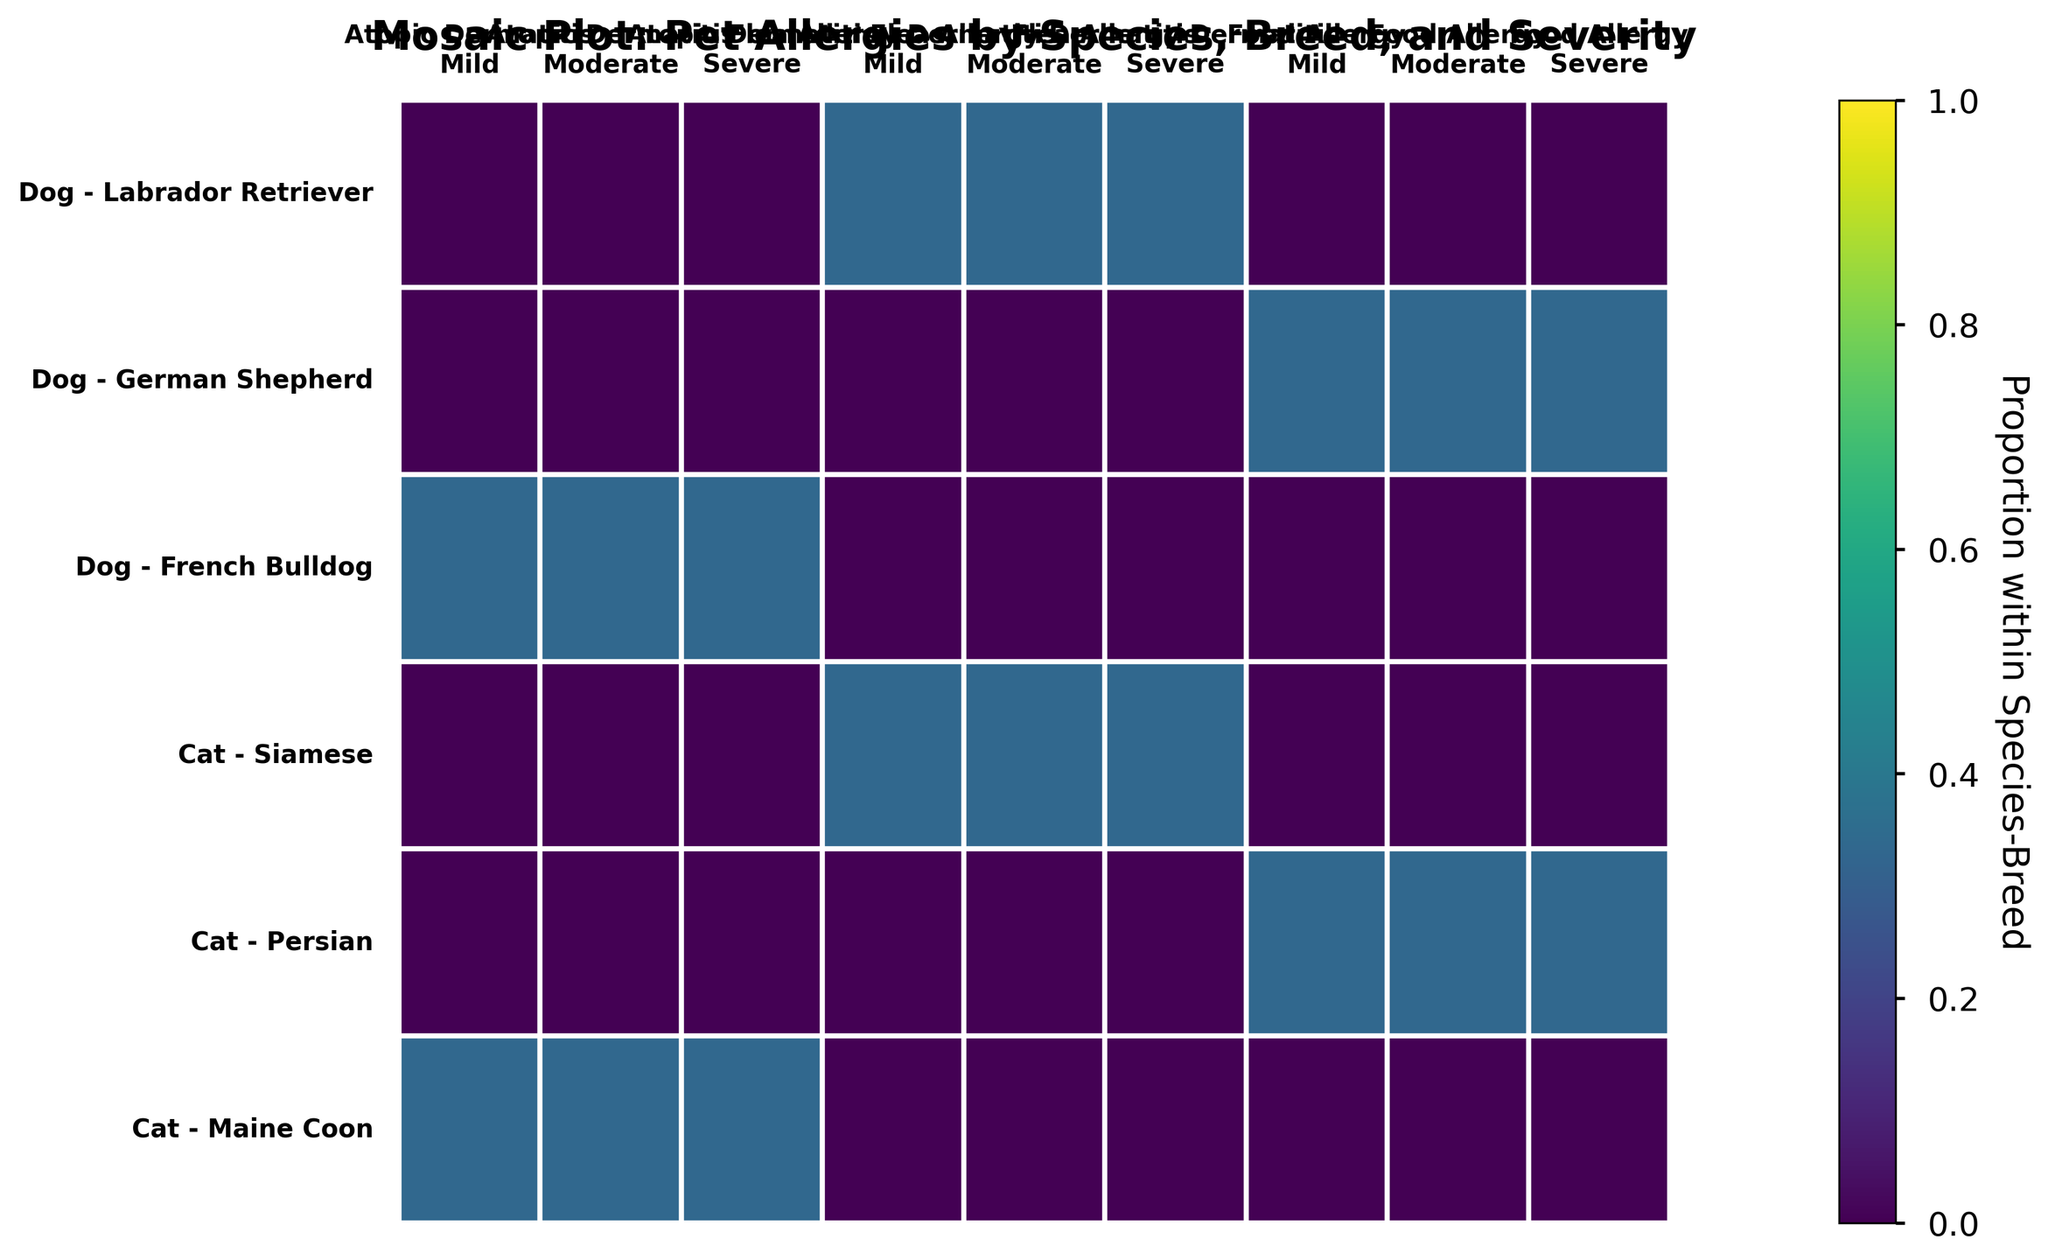What is the title of the figure? Look at the top of the figure to read the title.
Answer: Mosaic Plot: Pet Allergies by Species, Breed, and Severity Which breeds are shown for dogs? Identify the labels related to dog breeds on the y-axis: Labrador Retriever, German Shepherd, and French Bulldog.
Answer: Labrador Retriever, German Shepherd, French Bulldog Which allergy is marked as severe for French Bulldogs? Locate French Bulldogs in the y-axis and check the corresponding segments under 'Severe'. It's Atopic Dermatitis.
Answer: Atopic Dermatitis What proportion of the total plot area is occupied by the 'Moderate' severity of Food Allergy in German Shepherds? Identify the segment for 'Moderate' severity of Food Allergy in German Shepherds and compare the relative rectangular area it occupies in the mosaic plot.
Answer: Relatively small proportion Do cats or dogs have a higher prevalence of Atopic Dermatitis? Compare the total area occupied by rectangles representing Atopic Dermatitis across both species. Identify and sum up relevant sections for both species and compare.
Answer: Cats Which species has a higher prevalence of Flea Allergy Dermatitis? Compare the areas of rectangles for Flea Allergy Dermatitis between cats and dogs by examining the corresponding sections.
Answer: Cats Which breed has the highest severity level for Flea Allergy Dermatitis within the same species? Compare the sections marked 'Severe' under Flea Allergy Dermatitis for all breeds within either cats or dogs on the y-axis of the plot.
Answer: Labrador Retriever for dogs, Siamese for cats Is Food Allergy more prevalent in German Shepherds or Persians? Examine the areas representing Food Allergy for German Shepherds and Persians and determine which breed has a larger section.
Answer: Persian How does the prevalence of mild Atopic Dermatitis in French Bulldogs compare to that in Maine Coons? Compare the relative areas of the segments representing mild Atopic Dermatitis for both breeds.
Answer: Relatively equal What colors indicate the severity levels on the plot? Identify the color gradient from the lightest to the darkest rectangles in the mosaic plot associated with different severity levels.
Answer: Mild: light, Moderate: medium, Severe: dark What’s the general trend in severity levels for allergies among breeds? Aggregate the information by noting the distribution of mild, moderate, and severe severity levels across all breeds in the mosaic plot. Conclude on the presence of any common trend.
Answer: Mostly mild and moderate, fewer severe 